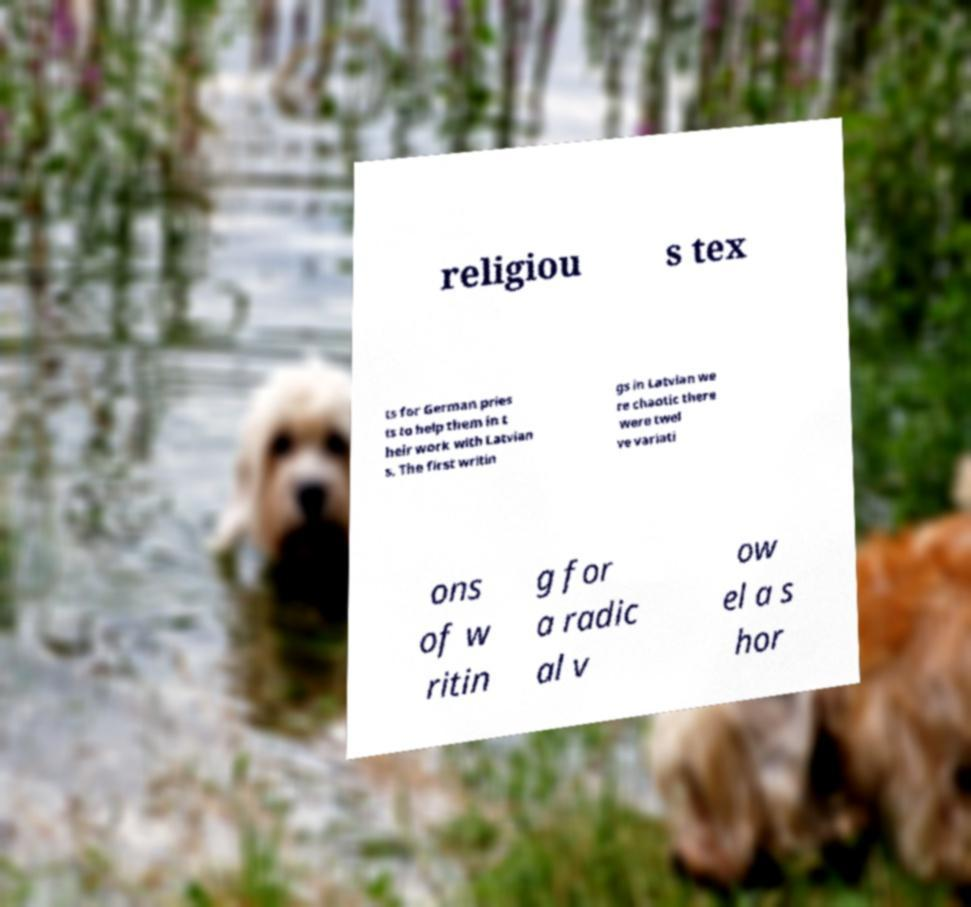Please identify and transcribe the text found in this image. religiou s tex ts for German pries ts to help them in t heir work with Latvian s. The first writin gs in Latvian we re chaotic there were twel ve variati ons of w ritin g for a radic al v ow el a s hor 